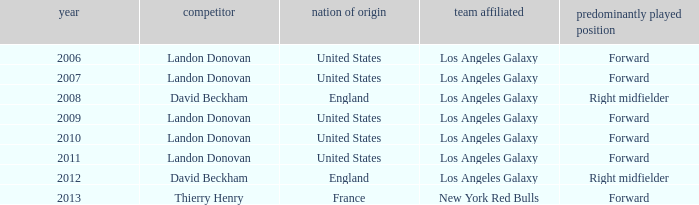What is the sum of all the years that Landon Donovan won the ESPY award? 5.0. 